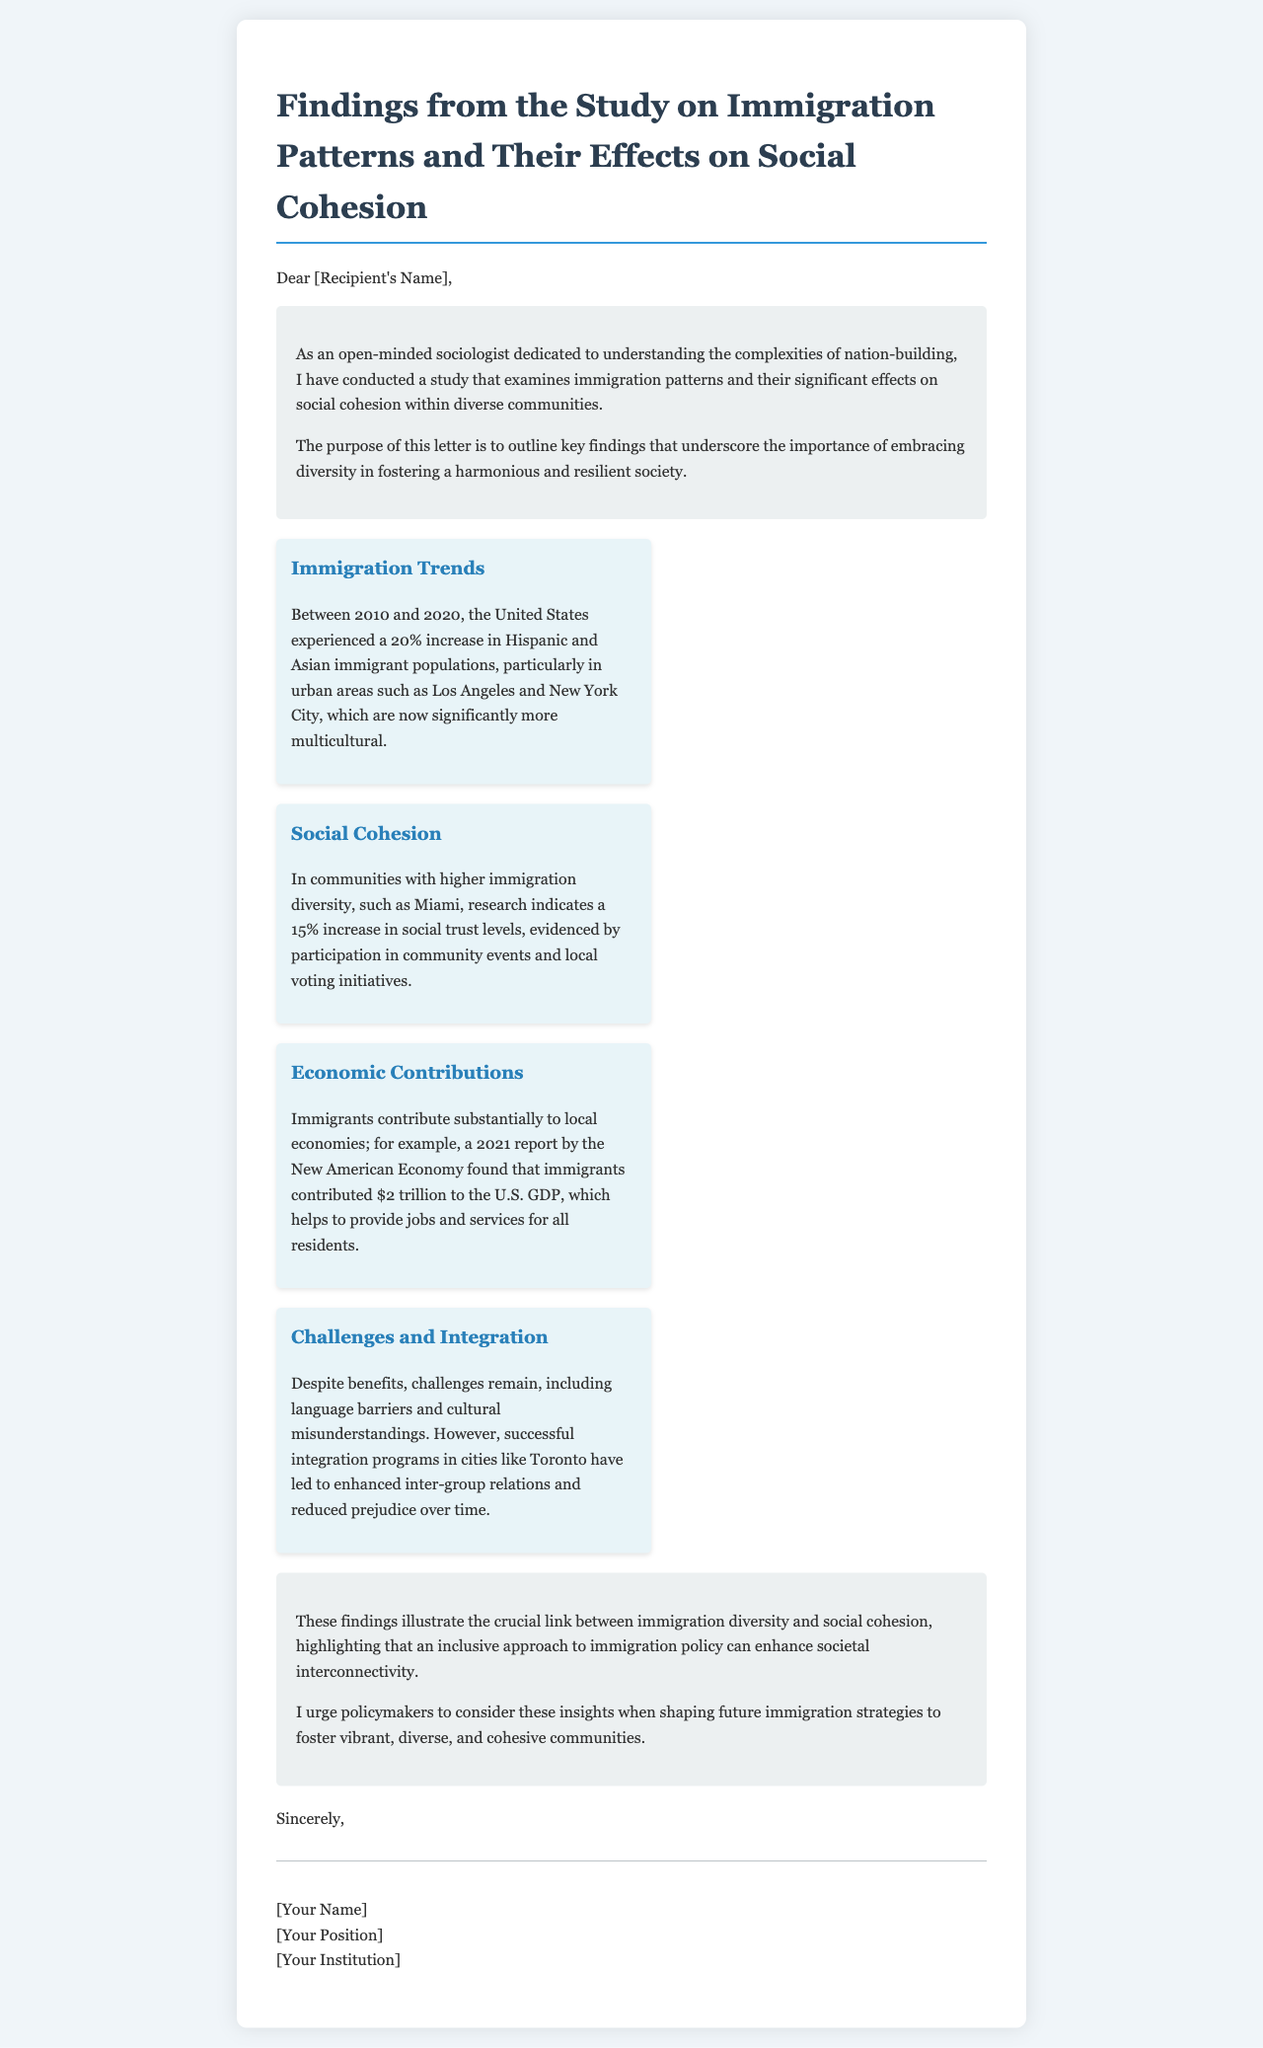what is the percentage increase in Hispanic and Asian immigrant populations from 2010 to 2020? The document states that there was a 20% increase in Hispanic and Asian immigrant populations during this period.
Answer: 20% which urban areas are mentioned as significantly more multicultural? The letter mentions urban areas such as Los Angeles and New York City explicitly as becoming more multicultural.
Answer: Los Angeles and New York City how much did immigrants contribute to the U.S. GDP according to the 2021 report? The document cites a 2021 report stating that immigrants contributed $2 trillion to the U.S. GDP.
Answer: $2 trillion what is the increase in social trust levels in communities with higher immigration diversity? The document indicates that there is a 15% increase in social trust levels in such communities.
Answer: 15% what aspect of immigration does the author urge policymakers to consider? The author emphasizes the importance of an inclusive approach to immigration policy to enhance societal interconnectivity.
Answer: Inclusive approach what are some reported challenges faced by immigrants? The letter identifies language barriers and cultural misunderstandings as reported challenges faced by immigrants.
Answer: Language barriers and cultural misunderstandings which city is mentioned as having successful integration programs? The document specifically names Toronto as a city with successful integration programs that enhance inter-group relations.
Answer: Toronto what does the study focus on in relation to social cohesion? The study examines the effects of immigration patterns on social cohesion within diverse communities, highlighting the importance of diversity.
Answer: Immigration patterns 